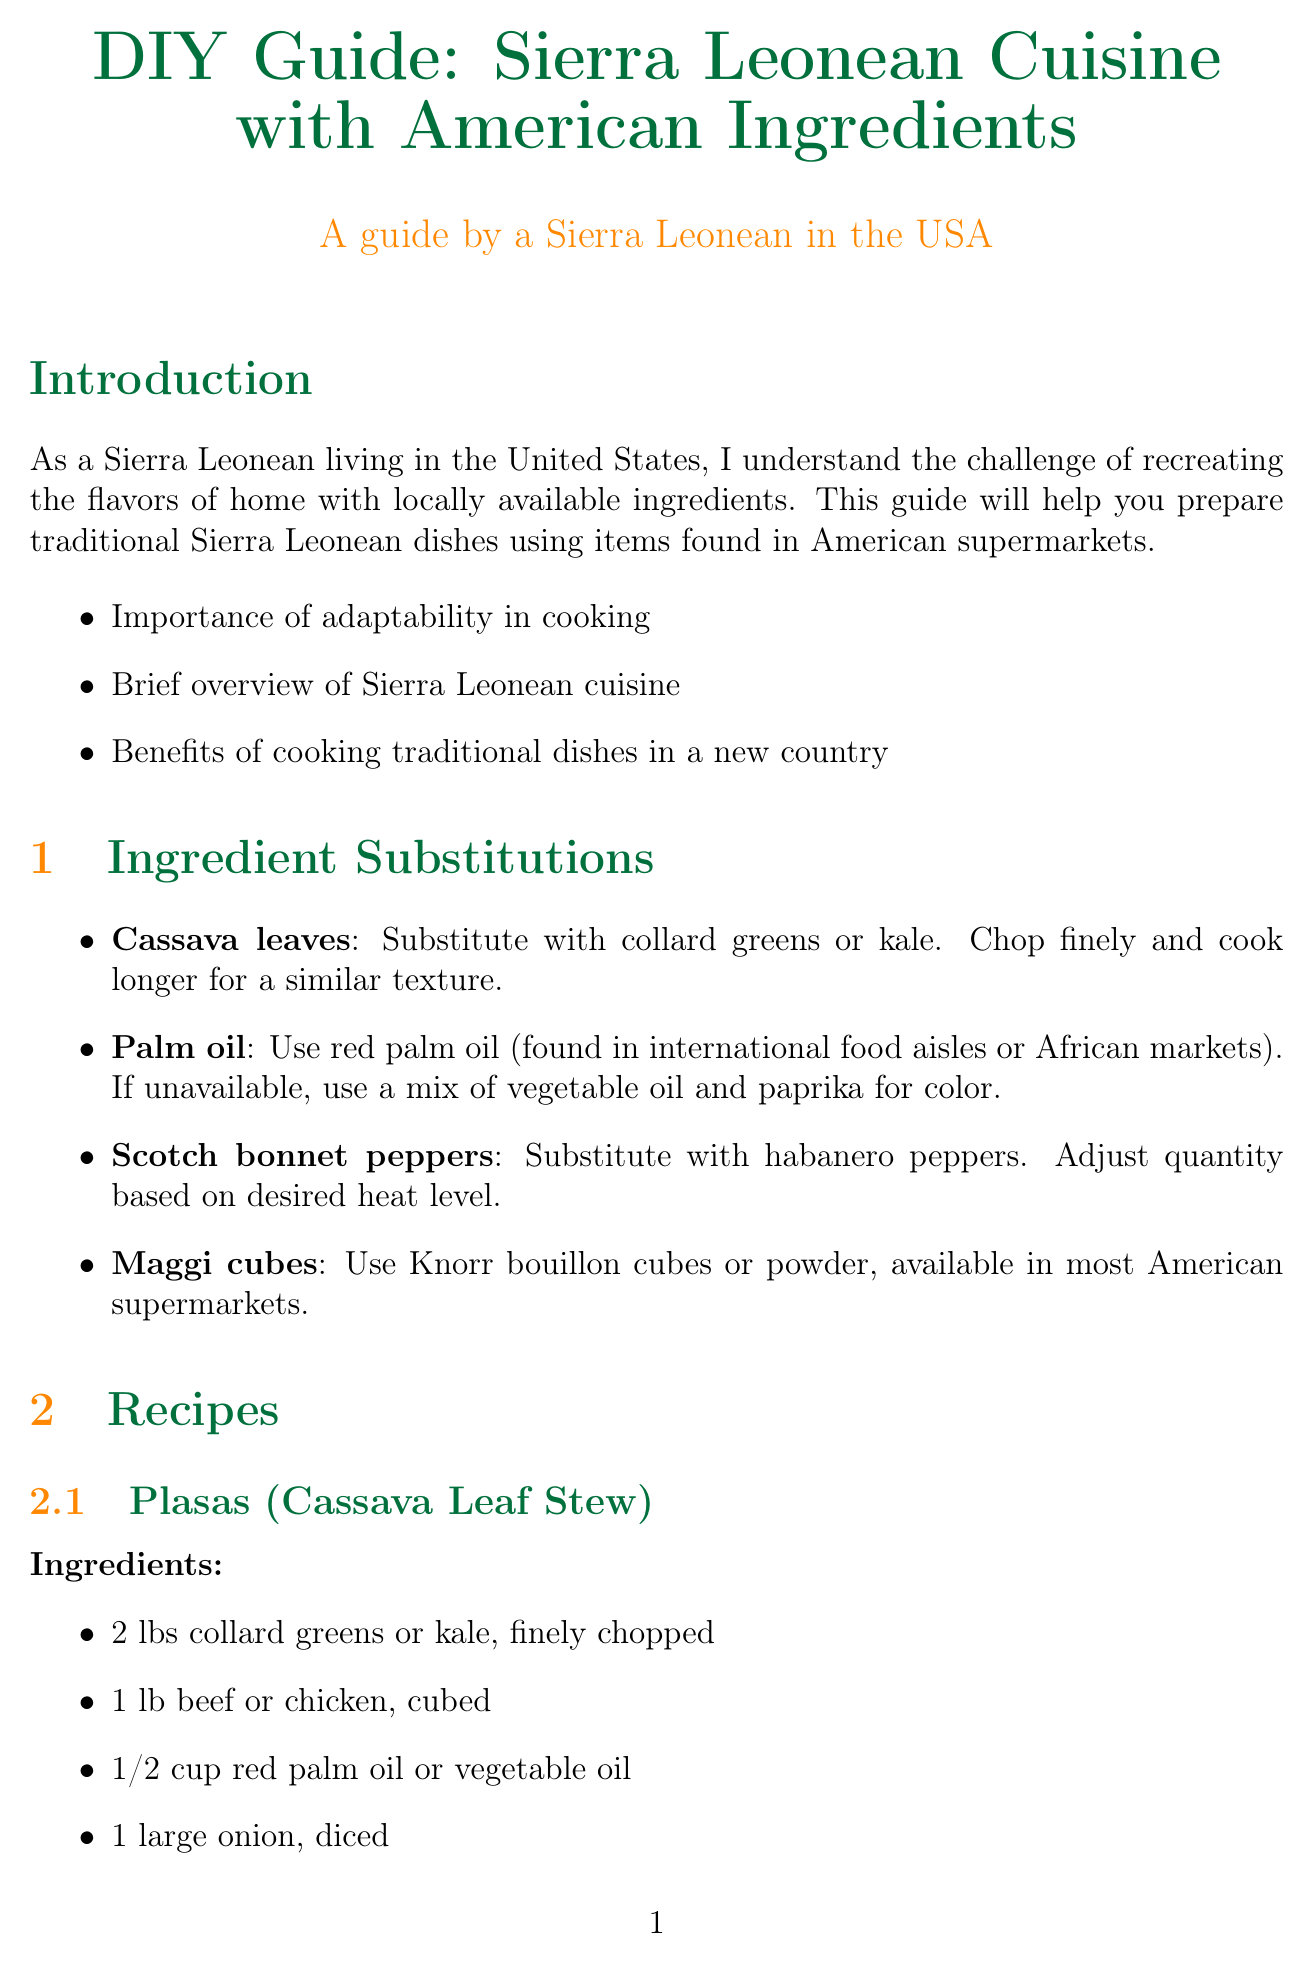What is the title of the guide? The title is stated at the beginning of the document as "DIY Guide: Sierra Leonean Cuisine with American Ingredients."
Answer: DIY Guide: Sierra Leonean Cuisine with American Ingredients What is suggested as a substitute for cassava leaves? The guide lists "collard greens or kale" as substitutes for cassava leaves under the ingredient substitutions section.
Answer: Collard greens or kale How many cups of long-grain rice are needed for Jollof Rice? The recipe for Jollof Rice specifies the need for "2 cups long-grain rice" in the ingredients list.
Answer: 2 cups What technique is recommended for achieving similar cooking results in less time? The document suggests using a "slow cooker or pressure cooker" to achieve similar results with less time and effort.
Answer: Slow cooker or pressure cooker What is the main purpose of sharing traditional dishes according to the cultural significance section? The document explains that cooking and sharing traditional dishes helps maintain a connection to heritage, introducing American friends to their culture.
Answer: Connection to heritage What quantity of habanero peppers is used in the Plasas recipe? The recipe for Plasas states to use "2 habanero peppers" in the ingredients list.
Answer: 2 habanero peppers What is one online resource mentioned for finding African grocery stores? The guide provides a specific online tool, "African Markets Locator," to find African grocery stores in your area.
Answer: African Markets Locator How many key points are listed under the introduction? The introduction contains "3 key points" that summarize the content of that section.
Answer: 3 key points What is the author of the Sierra Leone Cuisine Cookbook? The document names "Fatmata Binta" as the author of the Sierra Leone Cuisine Cookbook.
Answer: Fatmata Binta 